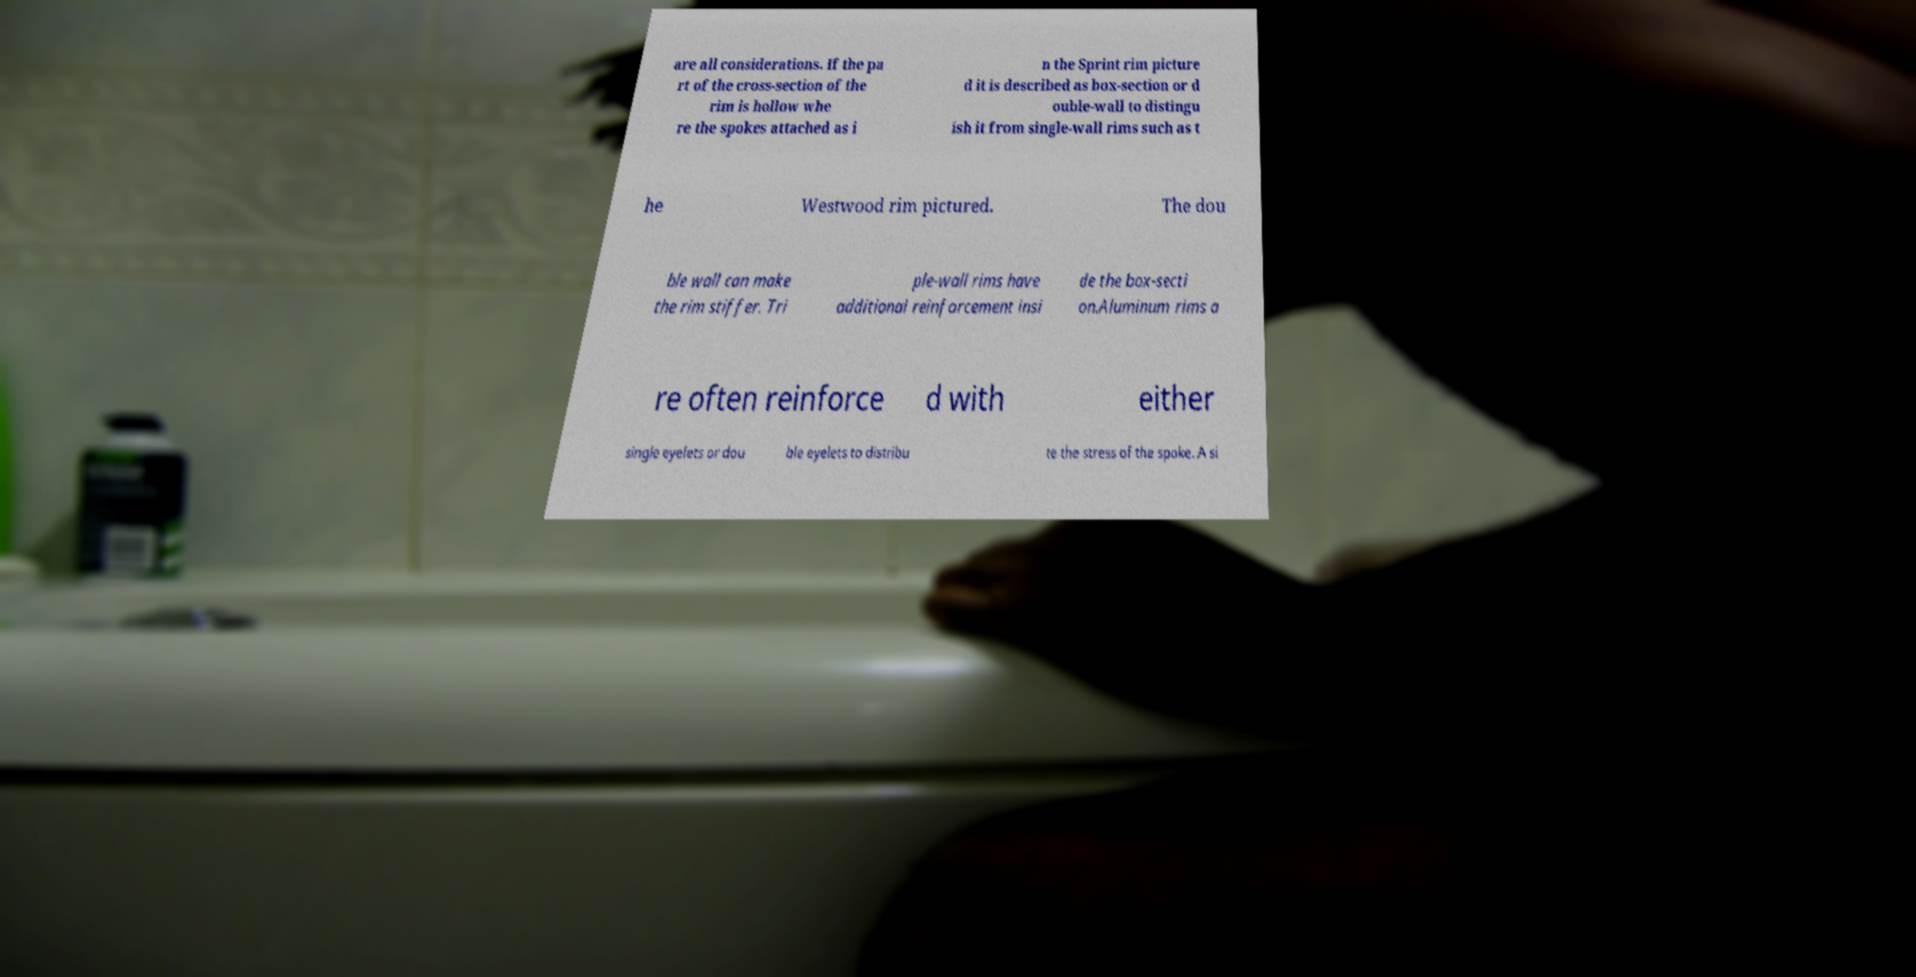Please read and relay the text visible in this image. What does it say? are all considerations. If the pa rt of the cross-section of the rim is hollow whe re the spokes attached as i n the Sprint rim picture d it is described as box-section or d ouble-wall to distingu ish it from single-wall rims such as t he Westwood rim pictured. The dou ble wall can make the rim stiffer. Tri ple-wall rims have additional reinforcement insi de the box-secti on.Aluminum rims a re often reinforce d with either single eyelets or dou ble eyelets to distribu te the stress of the spoke. A si 